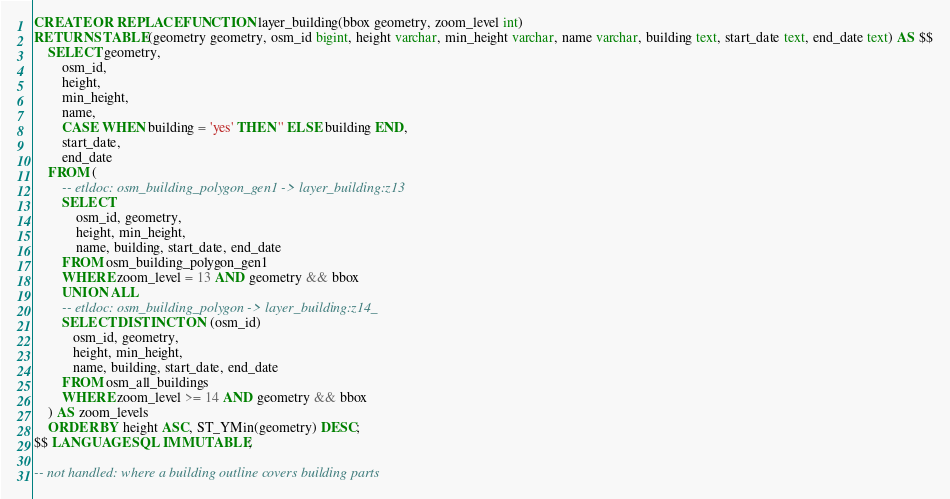Convert code to text. <code><loc_0><loc_0><loc_500><loc_500><_SQL_>
CREATE OR REPLACE FUNCTION layer_building(bbox geometry, zoom_level int)
RETURNS TABLE(geometry geometry, osm_id bigint, height varchar, min_height varchar, name varchar, building text, start_date text, end_date text) AS $$
    SELECT geometry,
        osm_id,
        height,
        min_height,
        name,
        CASE WHEN building = 'yes' THEN '' ELSE building END,
        start_date,
        end_date
    FROM (
        -- etldoc: osm_building_polygon_gen1 -> layer_building:z13
        SELECT
            osm_id, geometry,
            height, min_height,
            name, building, start_date, end_date
        FROM osm_building_polygon_gen1
        WHERE zoom_level = 13 AND geometry && bbox
        UNION ALL
        -- etldoc: osm_building_polygon -> layer_building:z14_
        SELECT DISTINCT ON (osm_id)
           osm_id, geometry,
           height, min_height,
           name, building, start_date, end_date
        FROM osm_all_buildings
        WHERE zoom_level >= 14 AND geometry && bbox
    ) AS zoom_levels
    ORDER BY height ASC, ST_YMin(geometry) DESC;
$$ LANGUAGE SQL IMMUTABLE;

-- not handled: where a building outline covers building parts
</code> 